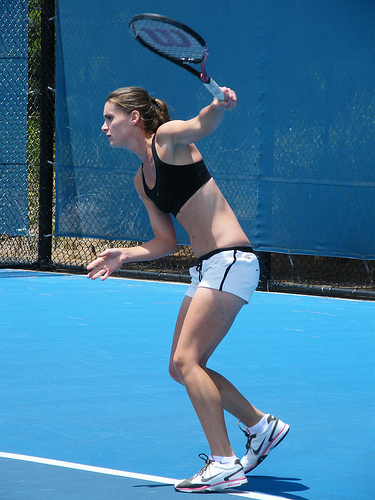The person is holding what? The person is gripping a tennis racket, which she is using to play the sport as observed in the image. 